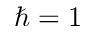Convert formula to latex. <formula><loc_0><loc_0><loc_500><loc_500>\hbar { = } 1</formula> 